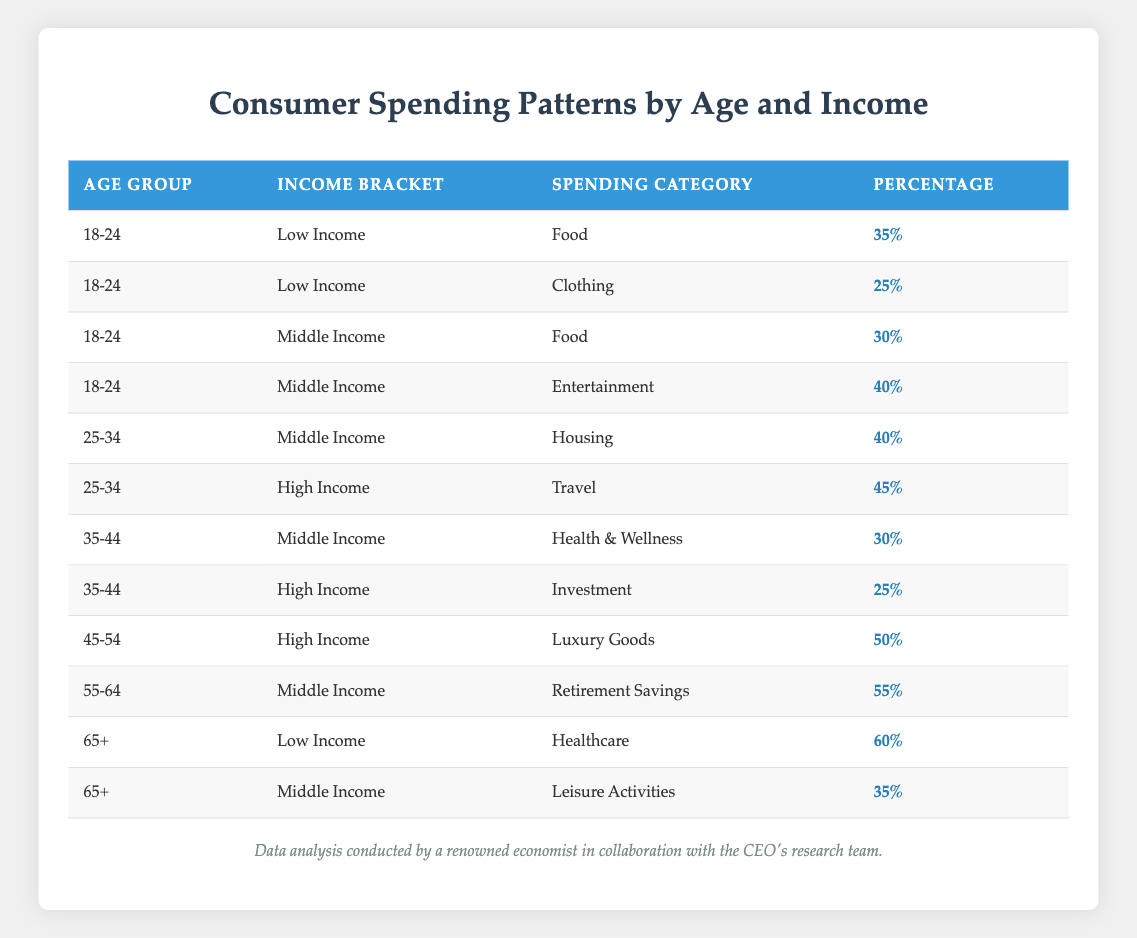What percentage of the 18-24 age group with low income spends on food? According to the table, the specific percentage for the 18-24 age group under the low-income bracket that spends on food is 35%.
Answer: 35% What is the spending percentage on luxury goods for the 45-54 age group with high income? From the table, it is clearly stated that the percentage for the 45-54 age group with high income spending on luxury goods is 50%.
Answer: 50% Which age group has the highest percentage of spending on retirement savings, and what is that percentage? The table indicates that the 55-64 age group has the highest percentage of spending on retirement savings, which is 55%.
Answer: 55% for the 55-64 age group Is there a spending category where the 65+ age group with low income spends more than 50%? Yes, according to the table, the 65+ age group with low income spends 60% on healthcare, which is greater than 50%.
Answer: Yes What is the sum of the spending percentages for the 25-34 age group across all income brackets? From the table, the spending percentages for the 25-34 age group are 40% (Middle Income - Housing) and 45% (High Income - Travel). Summing them gives 40 + 45 = 85%.
Answer: 85% What is the total percentage of spending on healthcare and leisure activities for the 65+ age group? The table indicates that the 65+ age group spends 60% on healthcare and 35% on leisure activities. Adding these percentages together results in 60 + 35 = 95%.
Answer: 95% Do more individuals in the 35-44 age group prefer health & wellness or investment? The table shows that the 35-44 age group spends 30% on health & wellness (Middle Income) and 25% on investment (High Income). Since 30% (Health & Wellness) is greater than 25% (Investment), more individuals prefer health & wellness.
Answer: Yes What is the average spending percentage on food for the 18-24 and 25-34 age groups combined? The 18-24 age group spends 35% (low income) and 30% (middle income) on food, totaling 65%. The 25-34 age group has no food category listed. Therefore, when only considering the provided data for food, the average is 65/2 = 32.5%.
Answer: 32.5% 